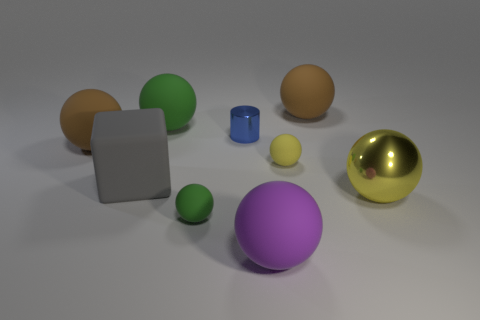Subtract 3 balls. How many balls are left? 4 Subtract all brown balls. How many balls are left? 5 Subtract all tiny green matte balls. How many balls are left? 6 Subtract all gray balls. Subtract all red cubes. How many balls are left? 7 Add 1 large gray matte balls. How many objects exist? 10 Subtract all cylinders. How many objects are left? 8 Subtract all brown metallic balls. Subtract all cylinders. How many objects are left? 8 Add 1 green rubber things. How many green rubber things are left? 3 Add 5 tiny green spheres. How many tiny green spheres exist? 6 Subtract 0 cyan blocks. How many objects are left? 9 